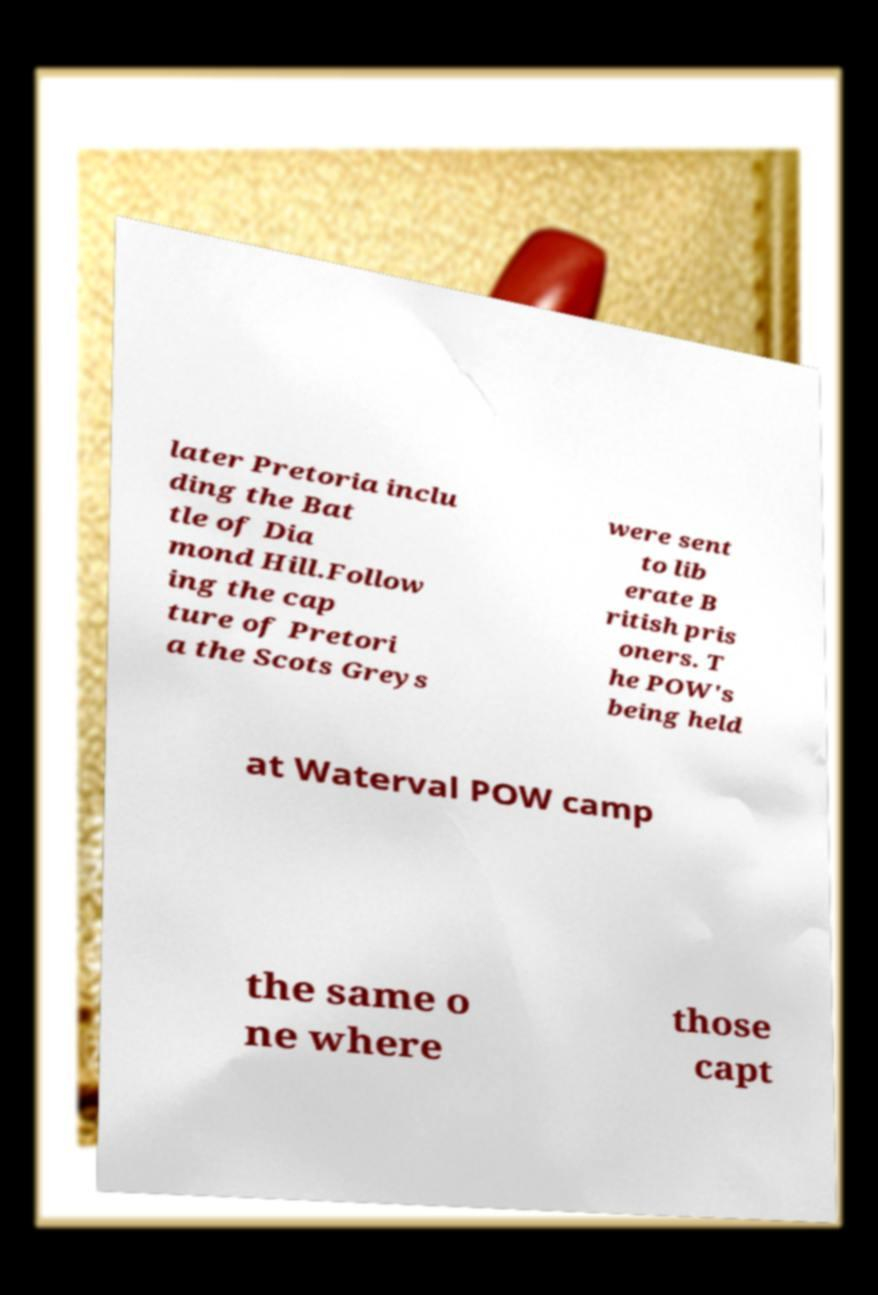For documentation purposes, I need the text within this image transcribed. Could you provide that? later Pretoria inclu ding the Bat tle of Dia mond Hill.Follow ing the cap ture of Pretori a the Scots Greys were sent to lib erate B ritish pris oners. T he POW's being held at Waterval POW camp the same o ne where those capt 